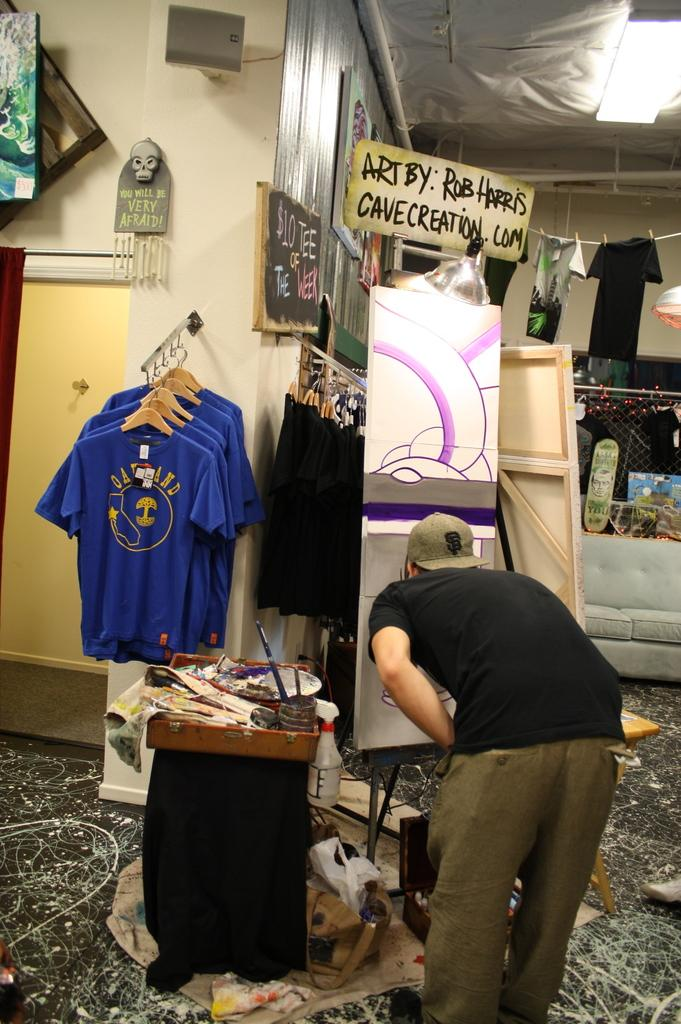<image>
Give a short and clear explanation of the subsequent image. an art display by Rob Harris with a website name of cavecreation.com 